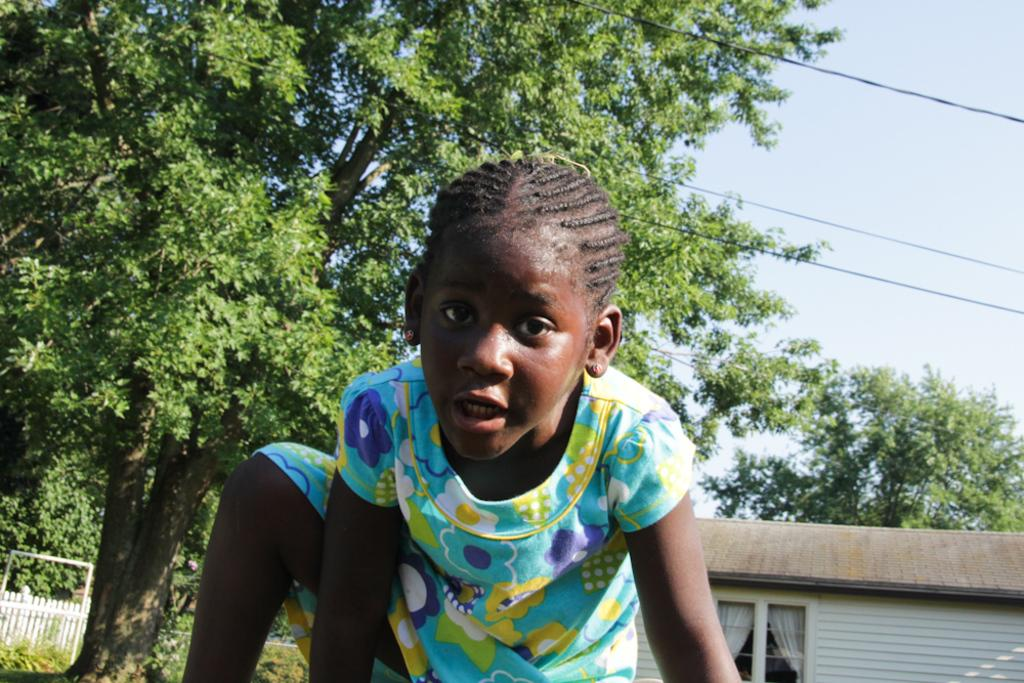What is the main subject of the image? There is a lady person in the image. What is the lady person wearing? The lady person is wearing a multi-color dress. What can be seen in the background of the image? There are trees, fencing, a house, and a clear sky in the background of the image. What type of game is being played in the image? There is no game being played in the image; it features a lady person in a multi-color dress with a background of trees, fencing, a house, and a clear sky. 